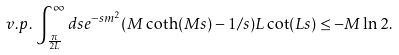<formula> <loc_0><loc_0><loc_500><loc_500>v . p . \, \int _ { \frac { \pi } { 2 L } } ^ { \infty } d s e ^ { - s m ^ { 2 } } ( M \coth ( M s ) - 1 / s ) L \cot ( L s ) \leq - M \ln 2 .</formula> 